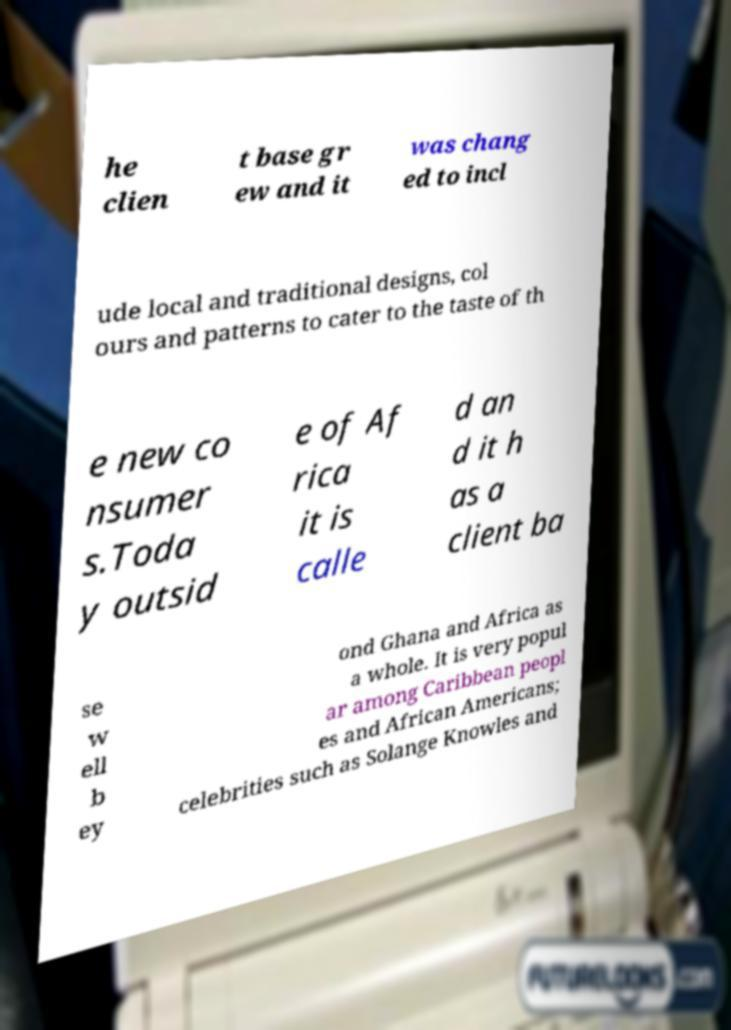Can you read and provide the text displayed in the image?This photo seems to have some interesting text. Can you extract and type it out for me? he clien t base gr ew and it was chang ed to incl ude local and traditional designs, col ours and patterns to cater to the taste of th e new co nsumer s.Toda y outsid e of Af rica it is calle d an d it h as a client ba se w ell b ey ond Ghana and Africa as a whole. It is very popul ar among Caribbean peopl es and African Americans; celebrities such as Solange Knowles and 